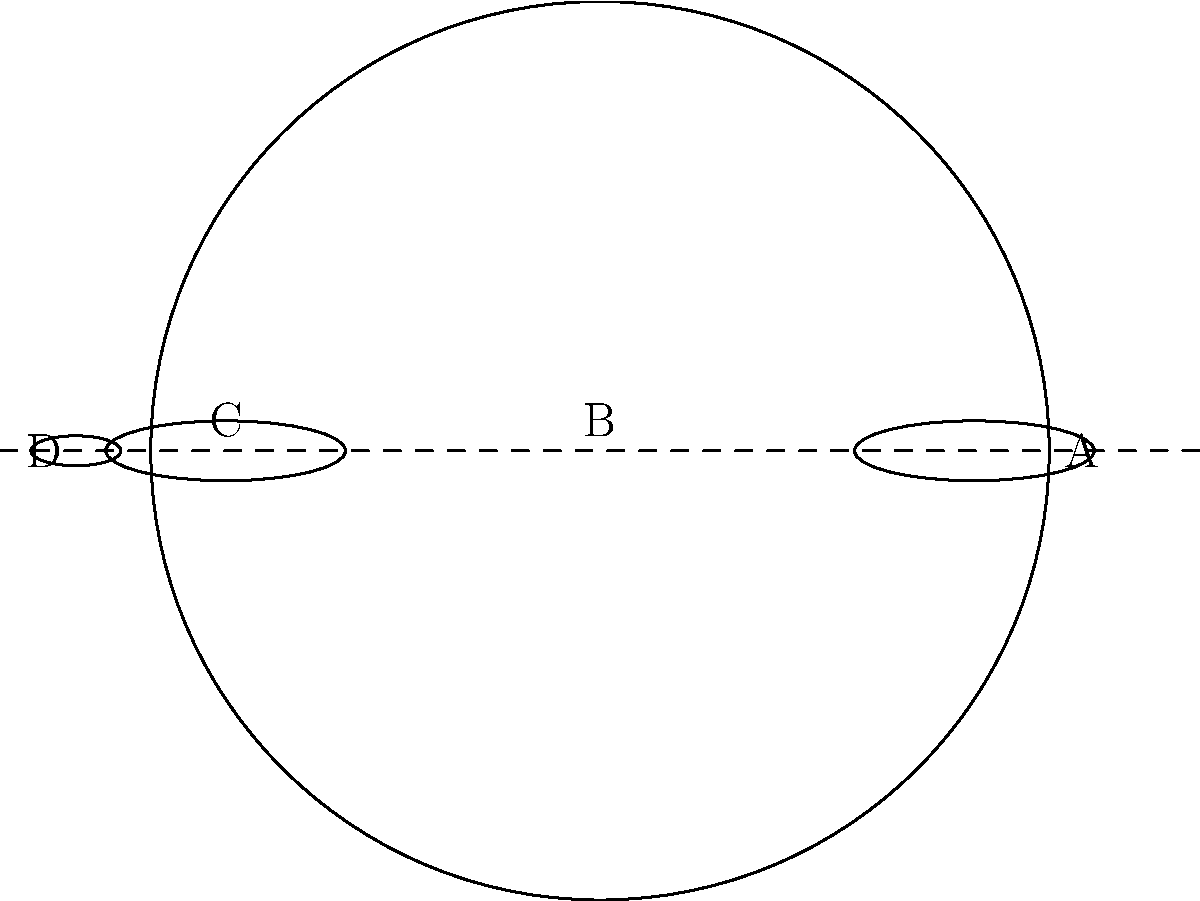In this simplified cross-section of a refracting telescope, which part labeled in the diagram is responsible for gathering and focusing light from distant objects? To answer this question, let's examine each labeled part of the telescope:

1. Part A: This large lens at the front of the telescope is called the objective lens. Its primary function is to gather light from distant objects and focus it inside the telescope tube.

2. Part B: This is the main body or tube of the telescope. It provides structural support and houses the optical components.

3. Part C: This smaller lens near the eyepiece is called the focusing lens. It helps to further focus the light coming from the objective lens.

4. Part D: This is the eyepiece, where the observer looks through to see the magnified image.

The part responsible for gathering and focusing light from distant objects is the objective lens, which is labeled A in the diagram. This large lens at the front of the telescope collects a large amount of light and focuses it to create a bright, clear image of distant celestial objects.
Answer: A (Objective lens) 